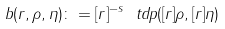Convert formula to latex. <formula><loc_0><loc_0><loc_500><loc_500>b ( r , \rho , \eta ) \colon = [ r ] ^ { - s } \ t d p ( [ r ] \rho , [ r ] \eta )</formula> 